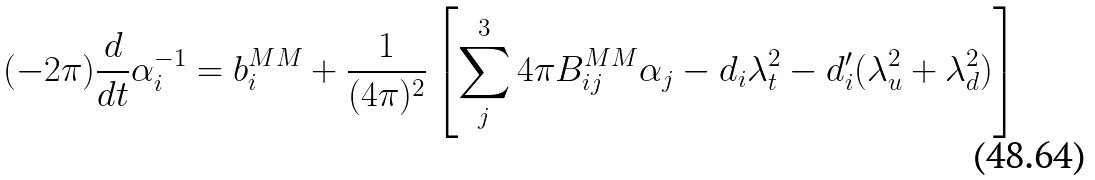<formula> <loc_0><loc_0><loc_500><loc_500>( - 2 \pi ) \frac { d } { d t } \alpha _ { i } ^ { - 1 } = b ^ { M M } _ { i } + \frac { 1 } { ( 4 \pi ) ^ { 2 } } \left [ \sum ^ { 3 } _ { j } 4 \pi B ^ { M M } _ { i j } \alpha _ { j } - d _ { i } \lambda _ { t } ^ { 2 } - d ^ { \prime } _ { i } ( \lambda _ { u } ^ { 2 } + \lambda _ { d } ^ { 2 } ) \right ]</formula> 